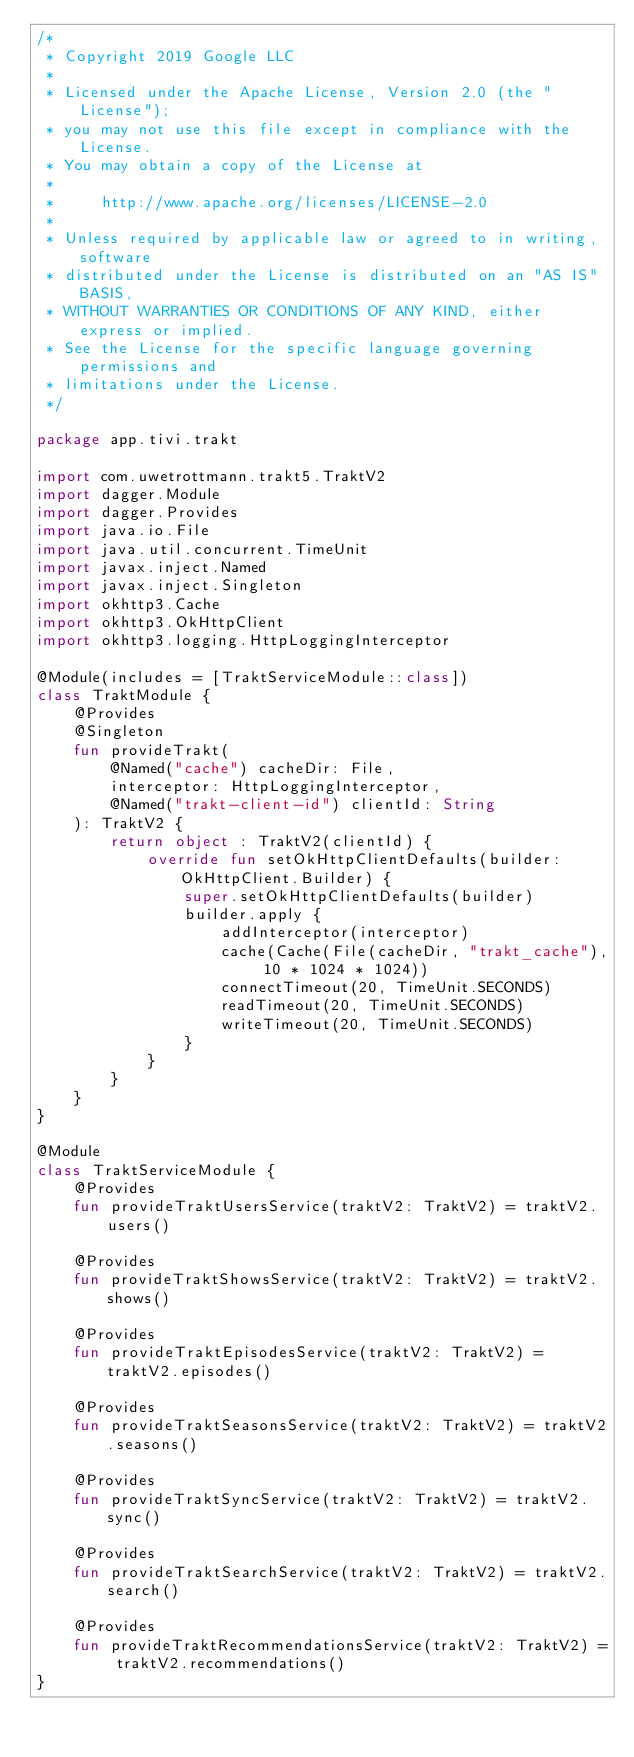Convert code to text. <code><loc_0><loc_0><loc_500><loc_500><_Kotlin_>/*
 * Copyright 2019 Google LLC
 *
 * Licensed under the Apache License, Version 2.0 (the "License");
 * you may not use this file except in compliance with the License.
 * You may obtain a copy of the License at
 *
 *     http://www.apache.org/licenses/LICENSE-2.0
 *
 * Unless required by applicable law or agreed to in writing, software
 * distributed under the License is distributed on an "AS IS" BASIS,
 * WITHOUT WARRANTIES OR CONDITIONS OF ANY KIND, either express or implied.
 * See the License for the specific language governing permissions and
 * limitations under the License.
 */

package app.tivi.trakt

import com.uwetrottmann.trakt5.TraktV2
import dagger.Module
import dagger.Provides
import java.io.File
import java.util.concurrent.TimeUnit
import javax.inject.Named
import javax.inject.Singleton
import okhttp3.Cache
import okhttp3.OkHttpClient
import okhttp3.logging.HttpLoggingInterceptor

@Module(includes = [TraktServiceModule::class])
class TraktModule {
    @Provides
    @Singleton
    fun provideTrakt(
        @Named("cache") cacheDir: File,
        interceptor: HttpLoggingInterceptor,
        @Named("trakt-client-id") clientId: String
    ): TraktV2 {
        return object : TraktV2(clientId) {
            override fun setOkHttpClientDefaults(builder: OkHttpClient.Builder) {
                super.setOkHttpClientDefaults(builder)
                builder.apply {
                    addInterceptor(interceptor)
                    cache(Cache(File(cacheDir, "trakt_cache"), 10 * 1024 * 1024))
                    connectTimeout(20, TimeUnit.SECONDS)
                    readTimeout(20, TimeUnit.SECONDS)
                    writeTimeout(20, TimeUnit.SECONDS)
                }
            }
        }
    }
}

@Module
class TraktServiceModule {
    @Provides
    fun provideTraktUsersService(traktV2: TraktV2) = traktV2.users()

    @Provides
    fun provideTraktShowsService(traktV2: TraktV2) = traktV2.shows()

    @Provides
    fun provideTraktEpisodesService(traktV2: TraktV2) = traktV2.episodes()

    @Provides
    fun provideTraktSeasonsService(traktV2: TraktV2) = traktV2.seasons()

    @Provides
    fun provideTraktSyncService(traktV2: TraktV2) = traktV2.sync()

    @Provides
    fun provideTraktSearchService(traktV2: TraktV2) = traktV2.search()

    @Provides
    fun provideTraktRecommendationsService(traktV2: TraktV2) = traktV2.recommendations()
}
</code> 